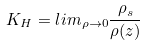<formula> <loc_0><loc_0><loc_500><loc_500>K _ { H } = l i m _ { \rho \rightarrow 0 } \frac { \rho _ { s } } { \rho ( z ) }</formula> 